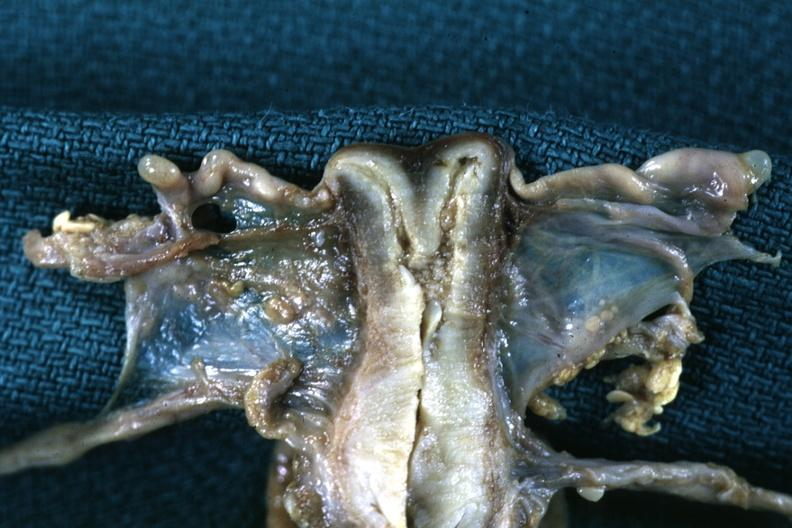what is present?
Answer the question using a single word or phrase. Uterus 